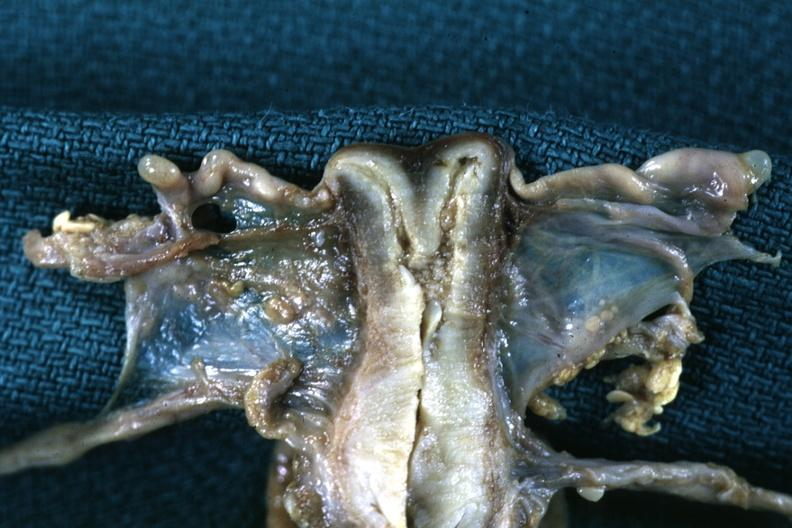what is present?
Answer the question using a single word or phrase. Uterus 